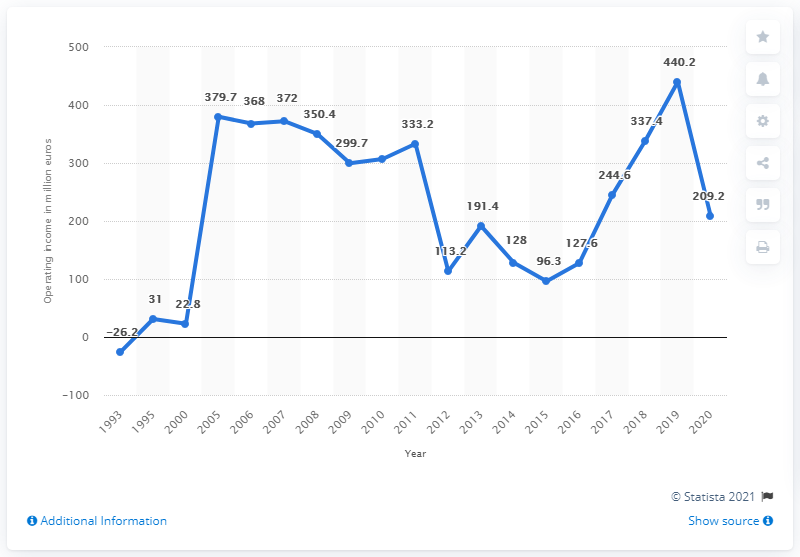Draw attention to some important aspects in this diagram. The average operating income from 1993 to 2007 was 191.22 dollars. The highest point on this graph occurred in the year 2019. In 2020, Puma's EBIT was 209.2 million. 